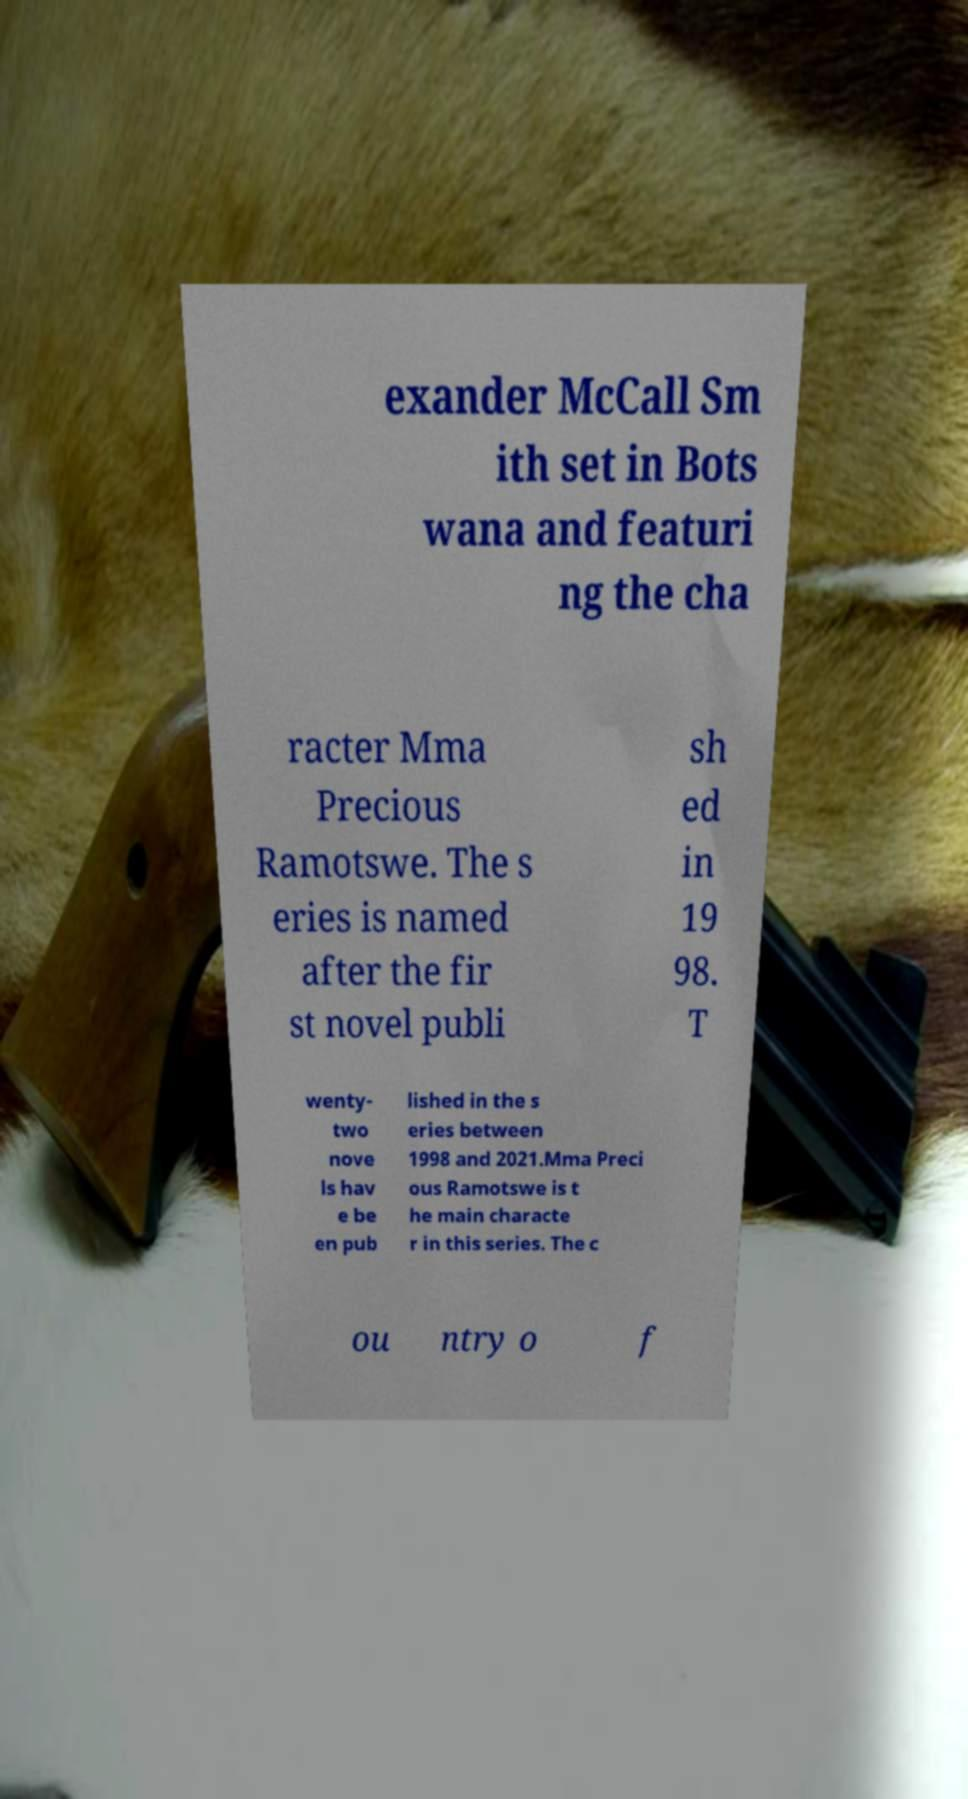Please identify and transcribe the text found in this image. exander McCall Sm ith set in Bots wana and featuri ng the cha racter Mma Precious Ramotswe. The s eries is named after the fir st novel publi sh ed in 19 98. T wenty- two nove ls hav e be en pub lished in the s eries between 1998 and 2021.Mma Preci ous Ramotswe is t he main characte r in this series. The c ou ntry o f 